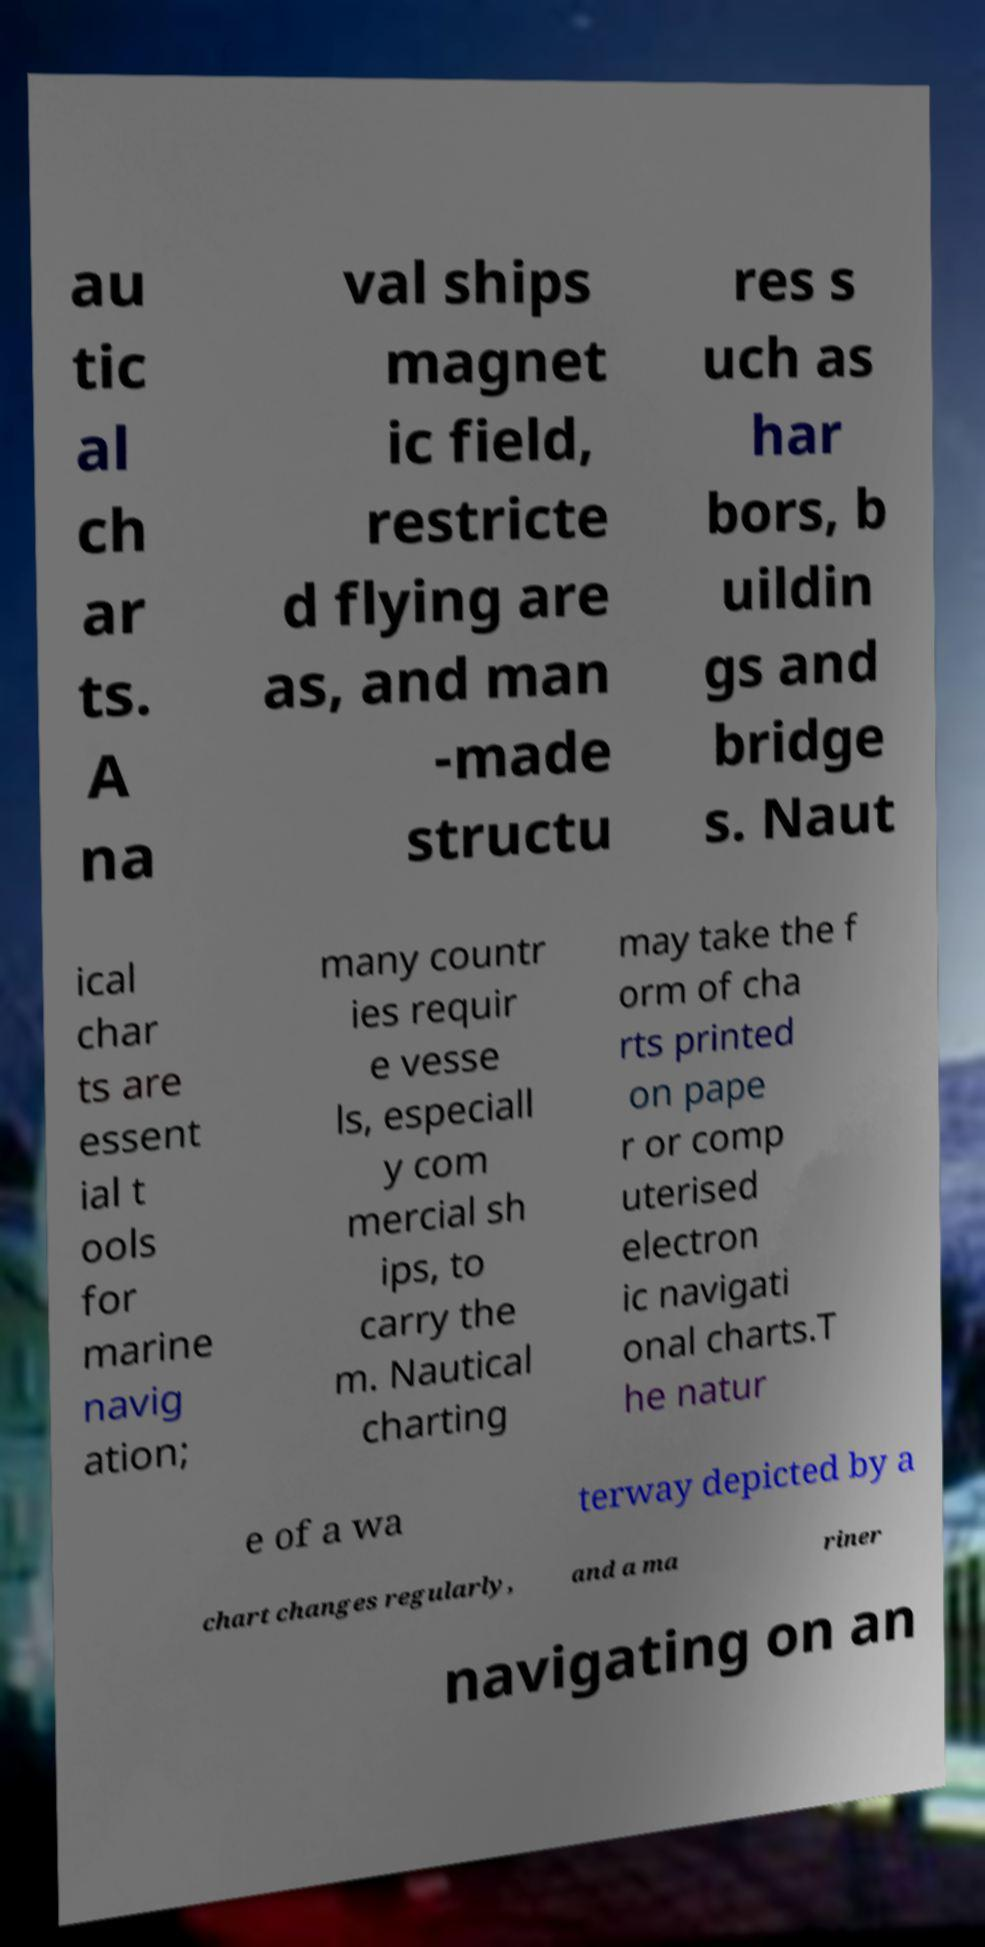Please read and relay the text visible in this image. What does it say? au tic al ch ar ts. A na val ships magnet ic field, restricte d flying are as, and man -made structu res s uch as har bors, b uildin gs and bridge s. Naut ical char ts are essent ial t ools for marine navig ation; many countr ies requir e vesse ls, especiall y com mercial sh ips, to carry the m. Nautical charting may take the f orm of cha rts printed on pape r or comp uterised electron ic navigati onal charts.T he natur e of a wa terway depicted by a chart changes regularly, and a ma riner navigating on an 